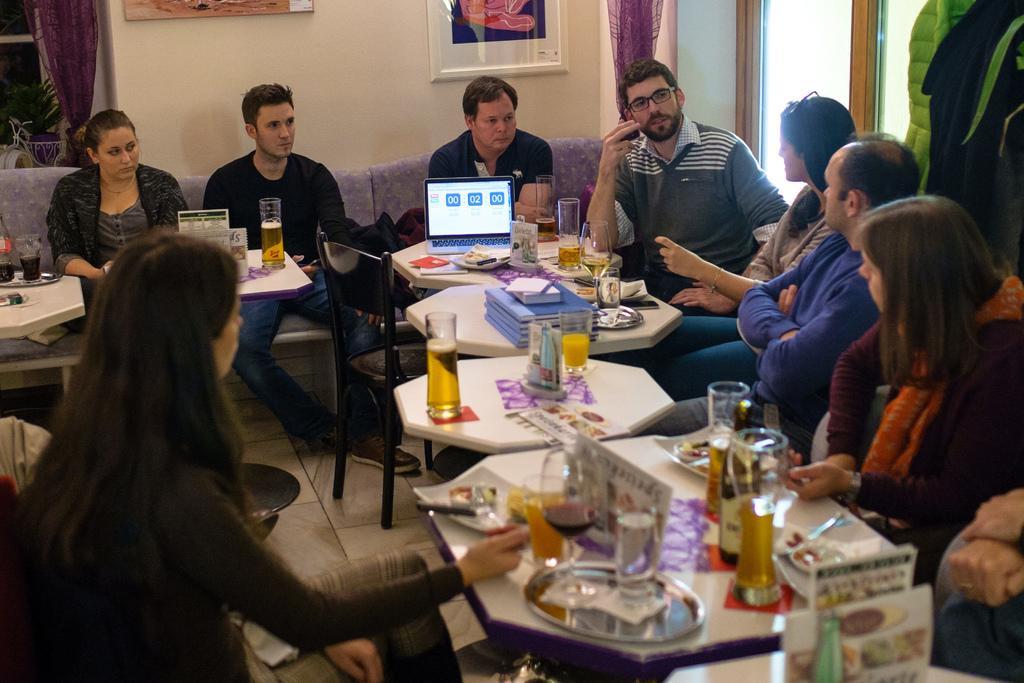Could you give a brief overview of what you see in this image? This picture is taken inside the room, There are some tables which are in white color on that tables there are some glasses some books and there is a laptop in white color on the table, There are some people sitting on the chairs around the tables, In the background there is a white color wall and there is a brown color door. 